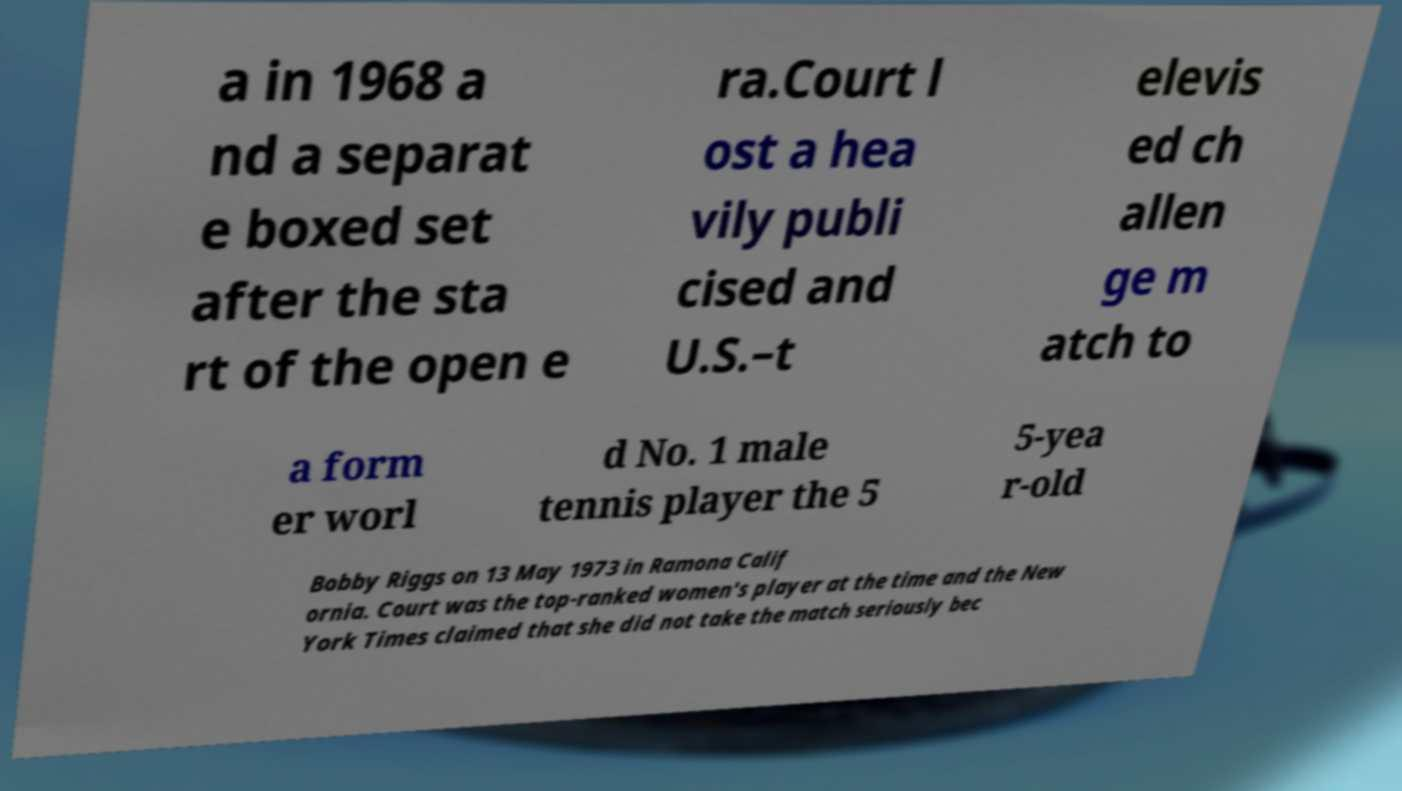Please read and relay the text visible in this image. What does it say? a in 1968 a nd a separat e boxed set after the sta rt of the open e ra.Court l ost a hea vily publi cised and U.S.–t elevis ed ch allen ge m atch to a form er worl d No. 1 male tennis player the 5 5-yea r-old Bobby Riggs on 13 May 1973 in Ramona Calif ornia. Court was the top-ranked women's player at the time and the New York Times claimed that she did not take the match seriously bec 